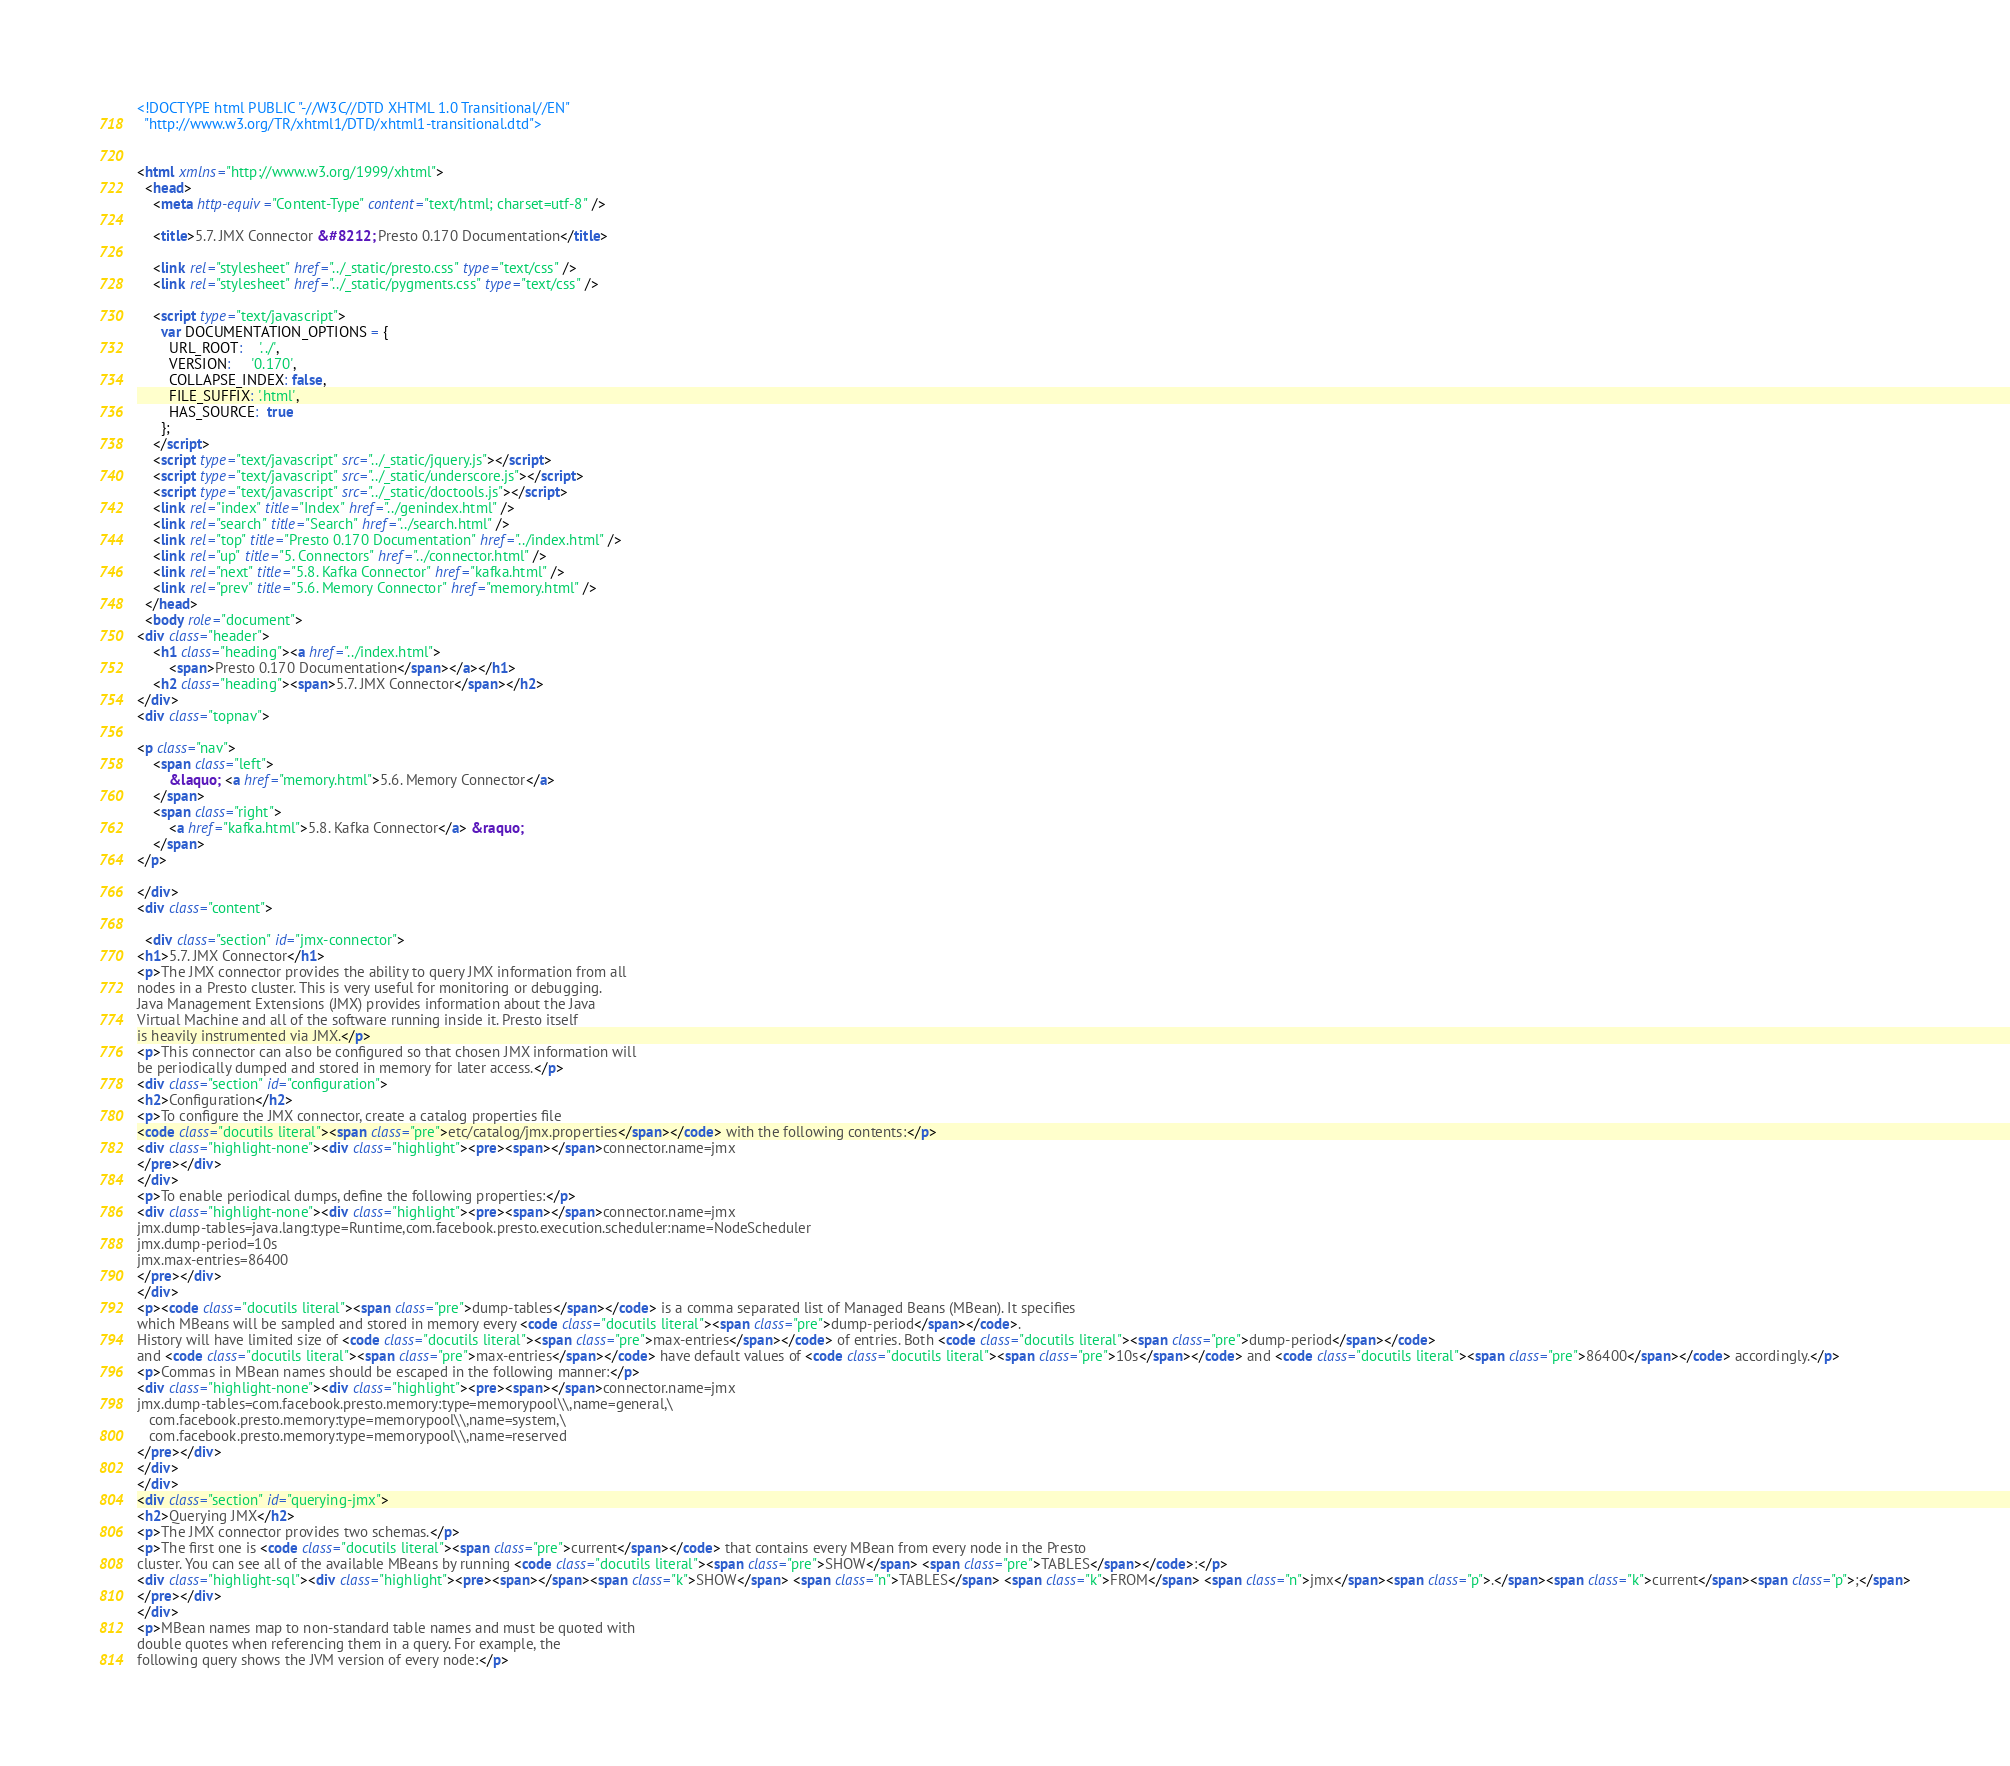<code> <loc_0><loc_0><loc_500><loc_500><_HTML_><!DOCTYPE html PUBLIC "-//W3C//DTD XHTML 1.0 Transitional//EN"
  "http://www.w3.org/TR/xhtml1/DTD/xhtml1-transitional.dtd">


<html xmlns="http://www.w3.org/1999/xhtml">
  <head>
    <meta http-equiv="Content-Type" content="text/html; charset=utf-8" />
    
    <title>5.7. JMX Connector &#8212; Presto 0.170 Documentation</title>
    
    <link rel="stylesheet" href="../_static/presto.css" type="text/css" />
    <link rel="stylesheet" href="../_static/pygments.css" type="text/css" />
    
    <script type="text/javascript">
      var DOCUMENTATION_OPTIONS = {
        URL_ROOT:    '../',
        VERSION:     '0.170',
        COLLAPSE_INDEX: false,
        FILE_SUFFIX: '.html',
        HAS_SOURCE:  true
      };
    </script>
    <script type="text/javascript" src="../_static/jquery.js"></script>
    <script type="text/javascript" src="../_static/underscore.js"></script>
    <script type="text/javascript" src="../_static/doctools.js"></script>
    <link rel="index" title="Index" href="../genindex.html" />
    <link rel="search" title="Search" href="../search.html" />
    <link rel="top" title="Presto 0.170 Documentation" href="../index.html" />
    <link rel="up" title="5. Connectors" href="../connector.html" />
    <link rel="next" title="5.8. Kafka Connector" href="kafka.html" />
    <link rel="prev" title="5.6. Memory Connector" href="memory.html" /> 
  </head>
  <body role="document">
<div class="header">
    <h1 class="heading"><a href="../index.html">
        <span>Presto 0.170 Documentation</span></a></h1>
    <h2 class="heading"><span>5.7. JMX Connector</span></h2>
</div>
<div class="topnav">
    
<p class="nav">
    <span class="left">
        &laquo; <a href="memory.html">5.6. Memory Connector</a>
    </span>
    <span class="right">
        <a href="kafka.html">5.8. Kafka Connector</a> &raquo;
    </span>
</p>

</div>
<div class="content">
    
  <div class="section" id="jmx-connector">
<h1>5.7. JMX Connector</h1>
<p>The JMX connector provides the ability to query JMX information from all
nodes in a Presto cluster. This is very useful for monitoring or debugging.
Java Management Extensions (JMX) provides information about the Java
Virtual Machine and all of the software running inside it. Presto itself
is heavily instrumented via JMX.</p>
<p>This connector can also be configured so that chosen JMX information will
be periodically dumped and stored in memory for later access.</p>
<div class="section" id="configuration">
<h2>Configuration</h2>
<p>To configure the JMX connector, create a catalog properties file
<code class="docutils literal"><span class="pre">etc/catalog/jmx.properties</span></code> with the following contents:</p>
<div class="highlight-none"><div class="highlight"><pre><span></span>connector.name=jmx
</pre></div>
</div>
<p>To enable periodical dumps, define the following properties:</p>
<div class="highlight-none"><div class="highlight"><pre><span></span>connector.name=jmx
jmx.dump-tables=java.lang:type=Runtime,com.facebook.presto.execution.scheduler:name=NodeScheduler
jmx.dump-period=10s
jmx.max-entries=86400
</pre></div>
</div>
<p><code class="docutils literal"><span class="pre">dump-tables</span></code> is a comma separated list of Managed Beans (MBean). It specifies
which MBeans will be sampled and stored in memory every <code class="docutils literal"><span class="pre">dump-period</span></code>.
History will have limited size of <code class="docutils literal"><span class="pre">max-entries</span></code> of entries. Both <code class="docutils literal"><span class="pre">dump-period</span></code>
and <code class="docutils literal"><span class="pre">max-entries</span></code> have default values of <code class="docutils literal"><span class="pre">10s</span></code> and <code class="docutils literal"><span class="pre">86400</span></code> accordingly.</p>
<p>Commas in MBean names should be escaped in the following manner:</p>
<div class="highlight-none"><div class="highlight"><pre><span></span>connector.name=jmx
jmx.dump-tables=com.facebook.presto.memory:type=memorypool\\,name=general,\
   com.facebook.presto.memory:type=memorypool\\,name=system,\
   com.facebook.presto.memory:type=memorypool\\,name=reserved
</pre></div>
</div>
</div>
<div class="section" id="querying-jmx">
<h2>Querying JMX</h2>
<p>The JMX connector provides two schemas.</p>
<p>The first one is <code class="docutils literal"><span class="pre">current</span></code> that contains every MBean from every node in the Presto
cluster. You can see all of the available MBeans by running <code class="docutils literal"><span class="pre">SHOW</span> <span class="pre">TABLES</span></code>:</p>
<div class="highlight-sql"><div class="highlight"><pre><span></span><span class="k">SHOW</span> <span class="n">TABLES</span> <span class="k">FROM</span> <span class="n">jmx</span><span class="p">.</span><span class="k">current</span><span class="p">;</span>
</pre></div>
</div>
<p>MBean names map to non-standard table names and must be quoted with
double quotes when referencing them in a query. For example, the
following query shows the JVM version of every node:</p></code> 